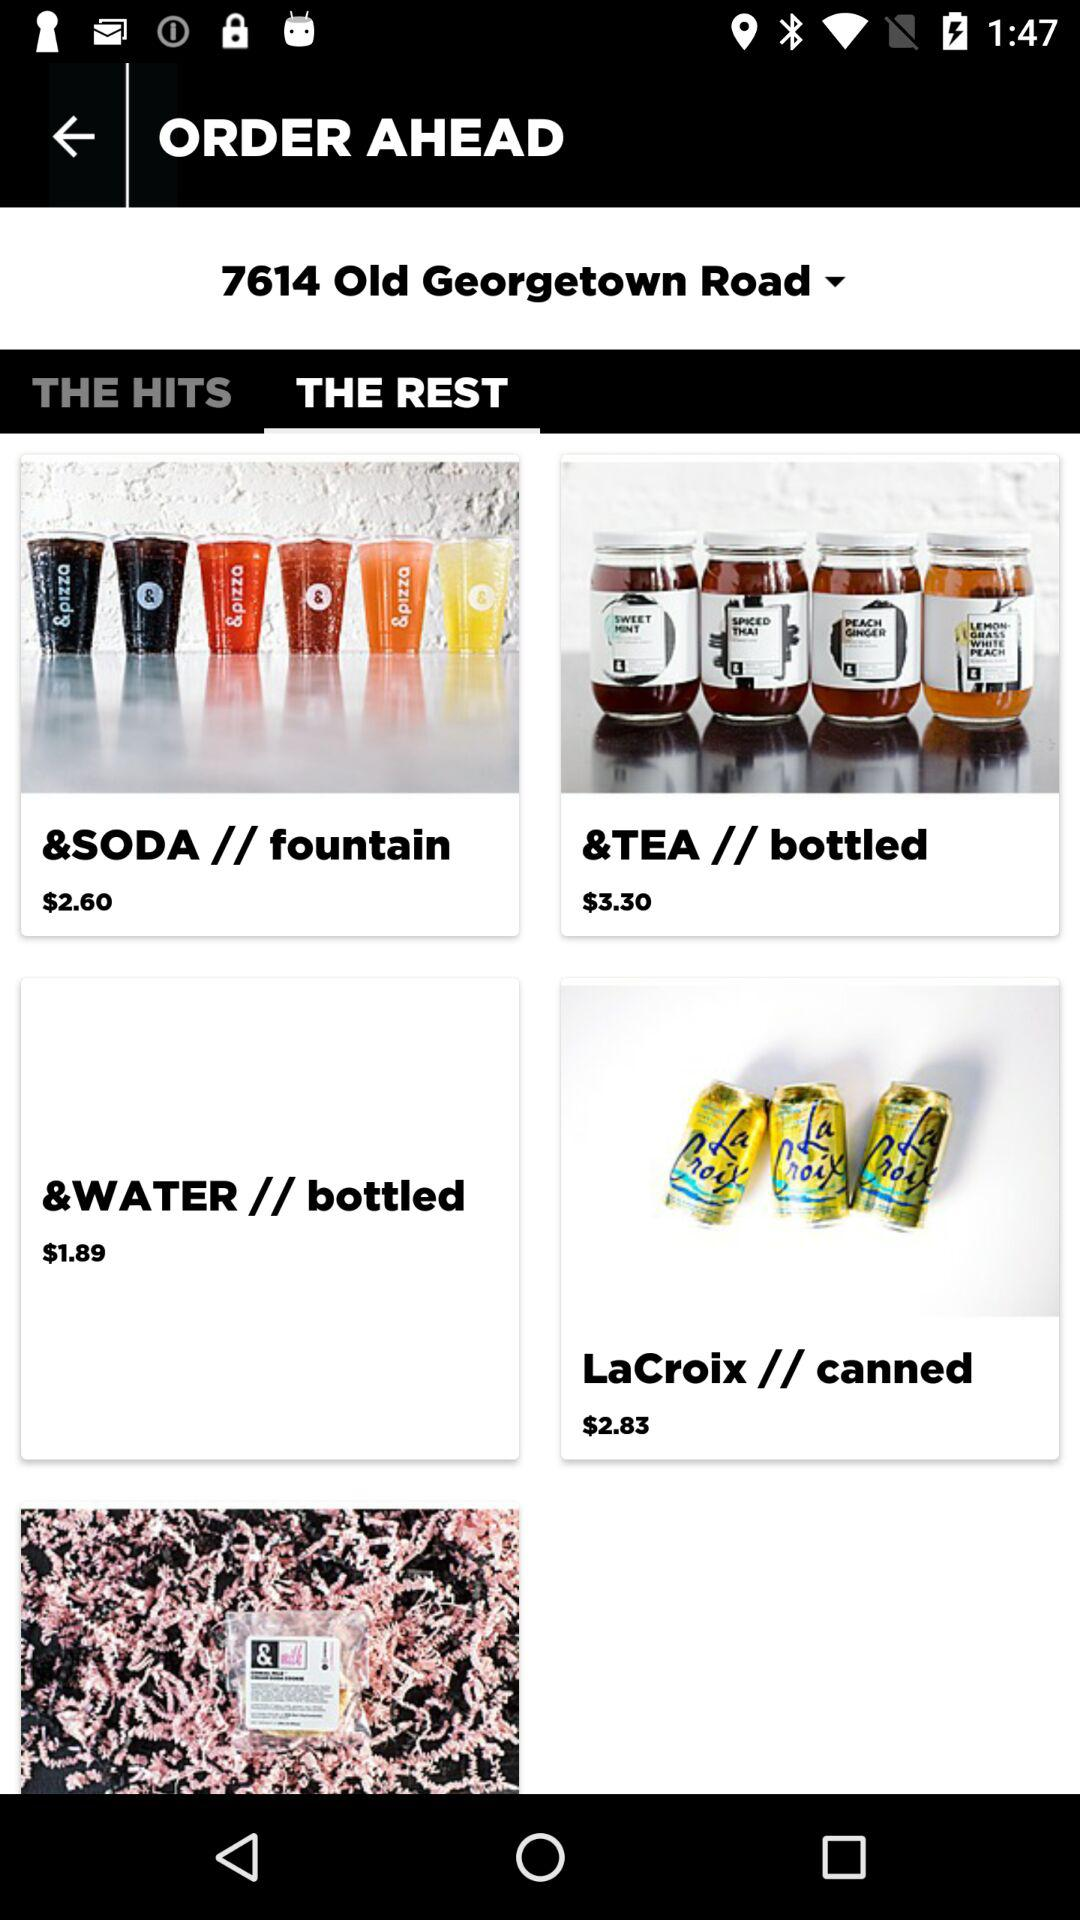Which items are listed under "THE HITS"?
When the provided information is insufficient, respond with <no answer>. <no answer> 